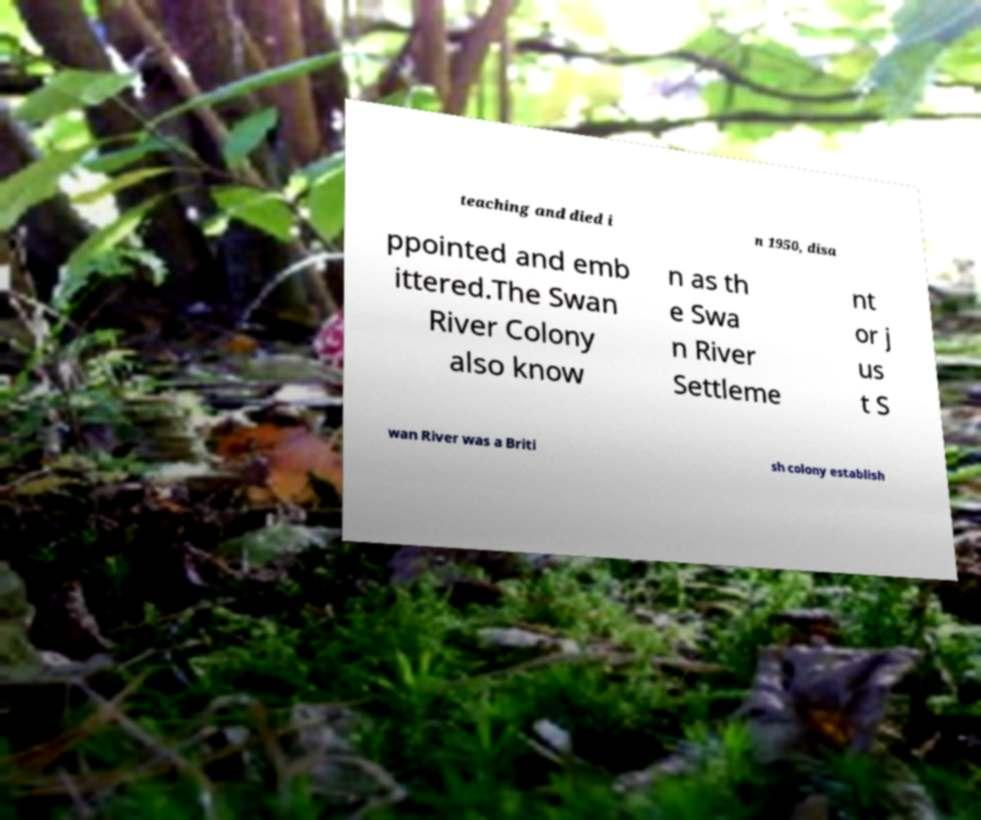There's text embedded in this image that I need extracted. Can you transcribe it verbatim? teaching and died i n 1950, disa ppointed and emb ittered.The Swan River Colony also know n as th e Swa n River Settleme nt or j us t S wan River was a Briti sh colony establish 